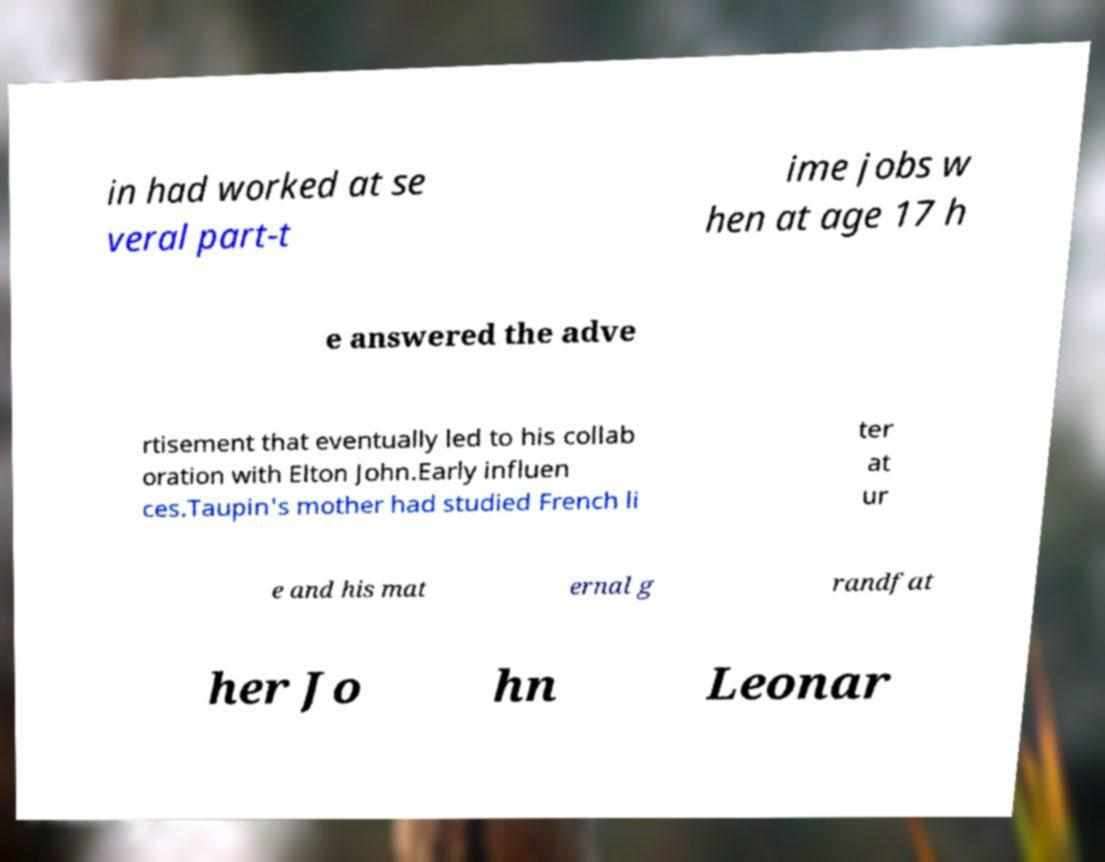Please read and relay the text visible in this image. What does it say? in had worked at se veral part-t ime jobs w hen at age 17 h e answered the adve rtisement that eventually led to his collab oration with Elton John.Early influen ces.Taupin's mother had studied French li ter at ur e and his mat ernal g randfat her Jo hn Leonar 